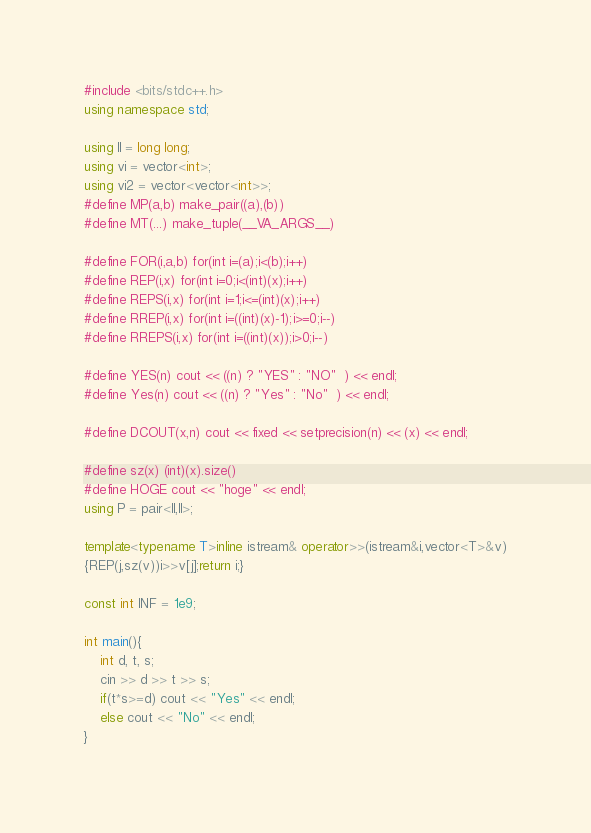Convert code to text. <code><loc_0><loc_0><loc_500><loc_500><_C++_>#include <bits/stdc++.h>
using namespace std;

using ll = long long;
using vi = vector<int>;
using vi2 = vector<vector<int>>;
#define MP(a,b) make_pair((a),(b))
#define MT(...) make_tuple(__VA_ARGS__)

#define FOR(i,a,b) for(int i=(a);i<(b);i++)
#define REP(i,x) for(int i=0;i<(int)(x);i++)
#define REPS(i,x) for(int i=1;i<=(int)(x);i++)
#define RREP(i,x) for(int i=((int)(x)-1);i>=0;i--)
#define RREPS(i,x) for(int i=((int)(x));i>0;i--)

#define YES(n) cout << ((n) ? "YES" : "NO"  ) << endl;
#define Yes(n) cout << ((n) ? "Yes" : "No"  ) << endl;

#define DCOUT(x,n) cout << fixed << setprecision(n) << (x) << endl;

#define sz(x) (int)(x).size()
#define HOGE cout << "hoge" << endl;
using P = pair<ll,ll>;

template<typename T>inline istream& operator>>(istream&i,vector<T>&v)
{REP(j,sz(v))i>>v[j];return i;}

const int INF = 1e9;

int main(){
    int d, t, s;
    cin >> d >> t >> s;
    if(t*s>=d) cout << "Yes" << endl;
    else cout << "No" << endl;
}</code> 